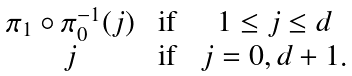Convert formula to latex. <formula><loc_0><loc_0><loc_500><loc_500>\begin{matrix} \pi _ { 1 } \circ \pi ^ { - 1 } _ { 0 } ( j ) & \text { if } & 1 \leq j \leq d \\ j & \text { if } & j = 0 , d + 1 . \end{matrix}</formula> 